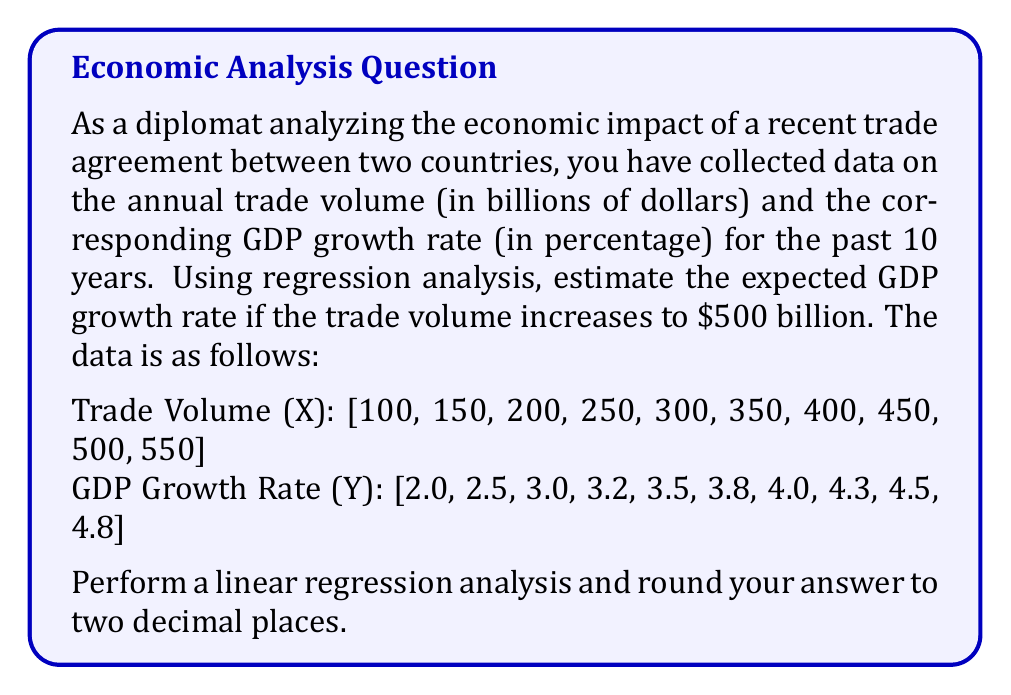Help me with this question. To solve this problem, we'll use linear regression analysis to find the relationship between trade volume (X) and GDP growth rate (Y). Then, we'll use the resulting equation to estimate the GDP growth rate for a trade volume of $500 billion.

Step 1: Calculate the means of X and Y
$$\bar{X} = \frac{\sum_{i=1}^{n} X_i}{n} = \frac{3300}{10} = 330$$
$$\bar{Y} = \frac{\sum_{i=1}^{n} Y_i}{n} = \frac{35.6}{10} = 3.56$$

Step 2: Calculate the slope (b) of the regression line
$$b = \frac{\sum_{i=1}^{n} (X_i - \bar{X})(Y_i - \bar{Y})}{\sum_{i=1}^{n} (X_i - \bar{X})^2}$$

Calculate the numerator and denominator separately:
Numerator: 1075
Denominator: 302500

$$b = \frac{1075}{302500} = 0.00355$$

Step 3: Calculate the y-intercept (a) of the regression line
$$a = \bar{Y} - b\bar{X} = 3.56 - (0.00355 \times 330) = 2.3885$$

Step 4: Form the regression equation
$$Y = a + bX = 2.3885 + 0.00355X$$

Step 5: Estimate the GDP growth rate for a trade volume of $500 billion
$$Y = 2.3885 + 0.00355 \times 500 = 4.1635$$

Rounding to two decimal places, we get 4.16%.
Answer: 4.16% 